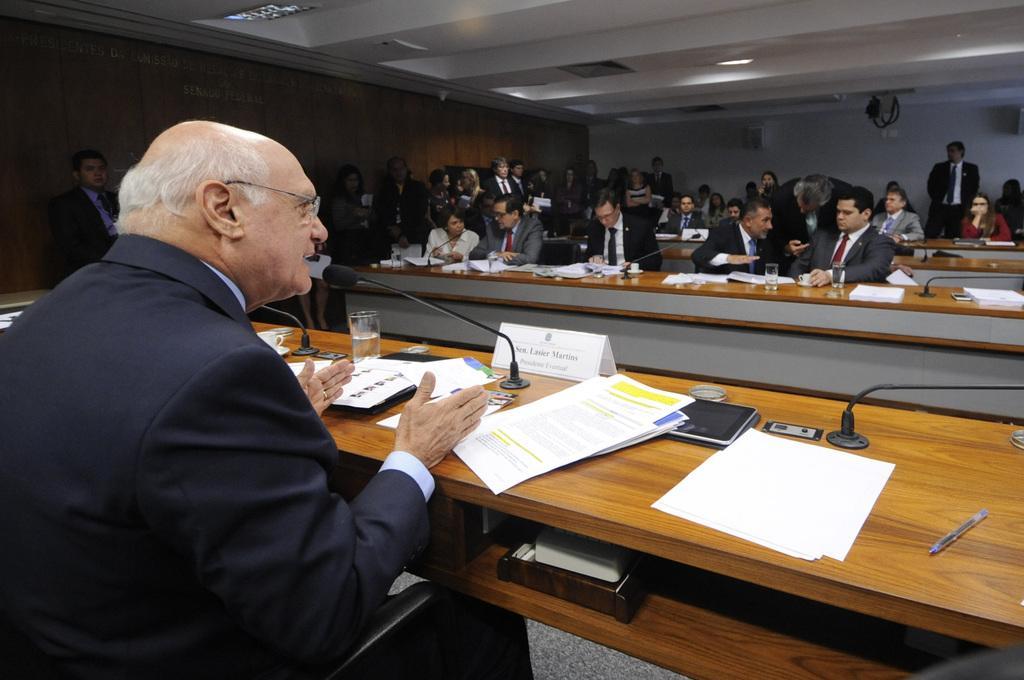How would you summarize this image in a sentence or two? This image I can see that a group of people who are sitting on a chair in front of a table. On the table we have microphone, piece of papers and other objects on it. 